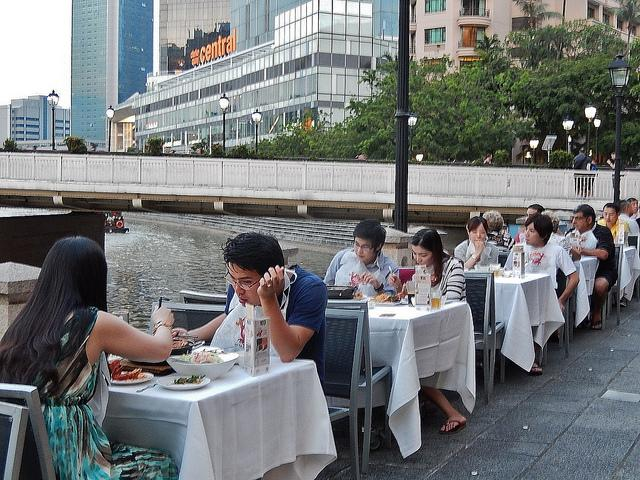What kind of meal are they having? lunch 